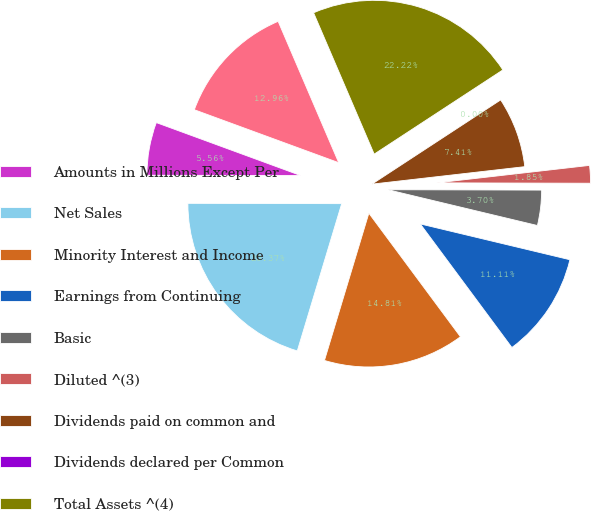Convert chart to OTSL. <chart><loc_0><loc_0><loc_500><loc_500><pie_chart><fcel>Amounts in Millions Except Per<fcel>Net Sales<fcel>Minority Interest and Income<fcel>Earnings from Continuing<fcel>Basic<fcel>Diluted ^(3)<fcel>Dividends paid on common and<fcel>Dividends declared per Common<fcel>Total Assets ^(4)<fcel>Cash and cash equivalents<nl><fcel>5.56%<fcel>20.37%<fcel>14.81%<fcel>11.11%<fcel>3.7%<fcel>1.85%<fcel>7.41%<fcel>0.0%<fcel>22.22%<fcel>12.96%<nl></chart> 